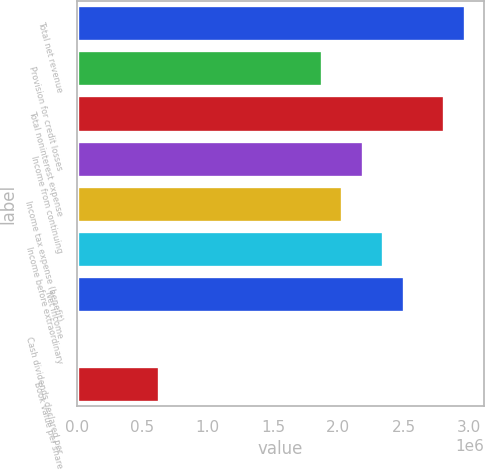<chart> <loc_0><loc_0><loc_500><loc_500><bar_chart><fcel>Total net revenue<fcel>Provision for credit losses<fcel>Total noninterest expense<fcel>Income from continuing<fcel>Income tax expense (benefit)<fcel>Income before extraordinary<fcel>Net income<fcel>Cash dividends declared per<fcel>Book value per share<nl><fcel>2.96808e+06<fcel>1.87458e+06<fcel>2.81186e+06<fcel>2.18701e+06<fcel>2.03079e+06<fcel>2.34322e+06<fcel>2.49943e+06<fcel>1.48<fcel>624860<nl></chart> 